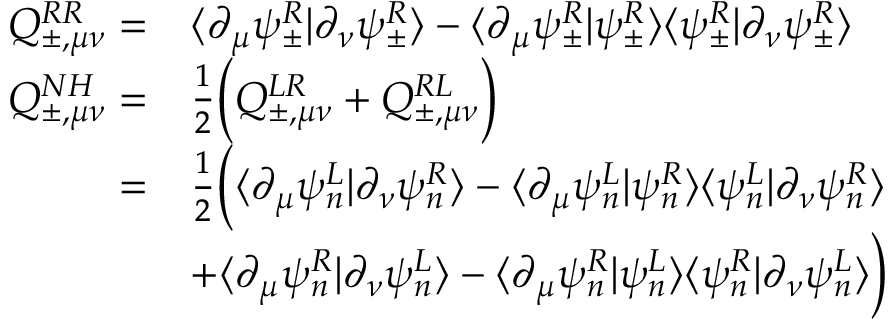<formula> <loc_0><loc_0><loc_500><loc_500>\begin{array} { r l } { Q _ { \pm , \mu \nu } ^ { R R } = } & { \langle \partial _ { \mu } \psi _ { \pm } ^ { R } | \partial _ { \nu } \psi _ { \pm } ^ { R } \rangle - \langle \partial _ { \mu } \psi _ { \pm } ^ { R } | \psi _ { \pm } ^ { R } \rangle \langle \psi _ { \pm } ^ { R } | \partial _ { \nu } \psi _ { \pm } ^ { R } \rangle } \\ { Q _ { \pm , \mu \nu } ^ { N H } = } & { \frac { 1 } { 2 } \left ( Q _ { \pm , \mu \nu } ^ { L R } + Q _ { \pm , \mu \nu } ^ { R L } \right ) } \\ { = } & { \frac { 1 } { 2 } \left ( \langle \partial _ { \mu } \psi _ { n } ^ { L } | \partial _ { \nu } \psi _ { n } ^ { R } \rangle - \langle \partial _ { \mu } \psi _ { n } ^ { L } | \psi _ { n } ^ { R } \rangle \langle \psi _ { n } ^ { L } | \partial _ { \nu } \psi _ { n } ^ { R } \rangle } \\ & { + \langle \partial _ { \mu } \psi _ { n } ^ { R } | \partial _ { \nu } \psi _ { n } ^ { L } \rangle - \langle \partial _ { \mu } \psi _ { n } ^ { R } | \psi _ { n } ^ { L } \rangle \langle \psi _ { n } ^ { R } | \partial _ { \nu } \psi _ { n } ^ { L } \rangle \right ) } \end{array}</formula> 